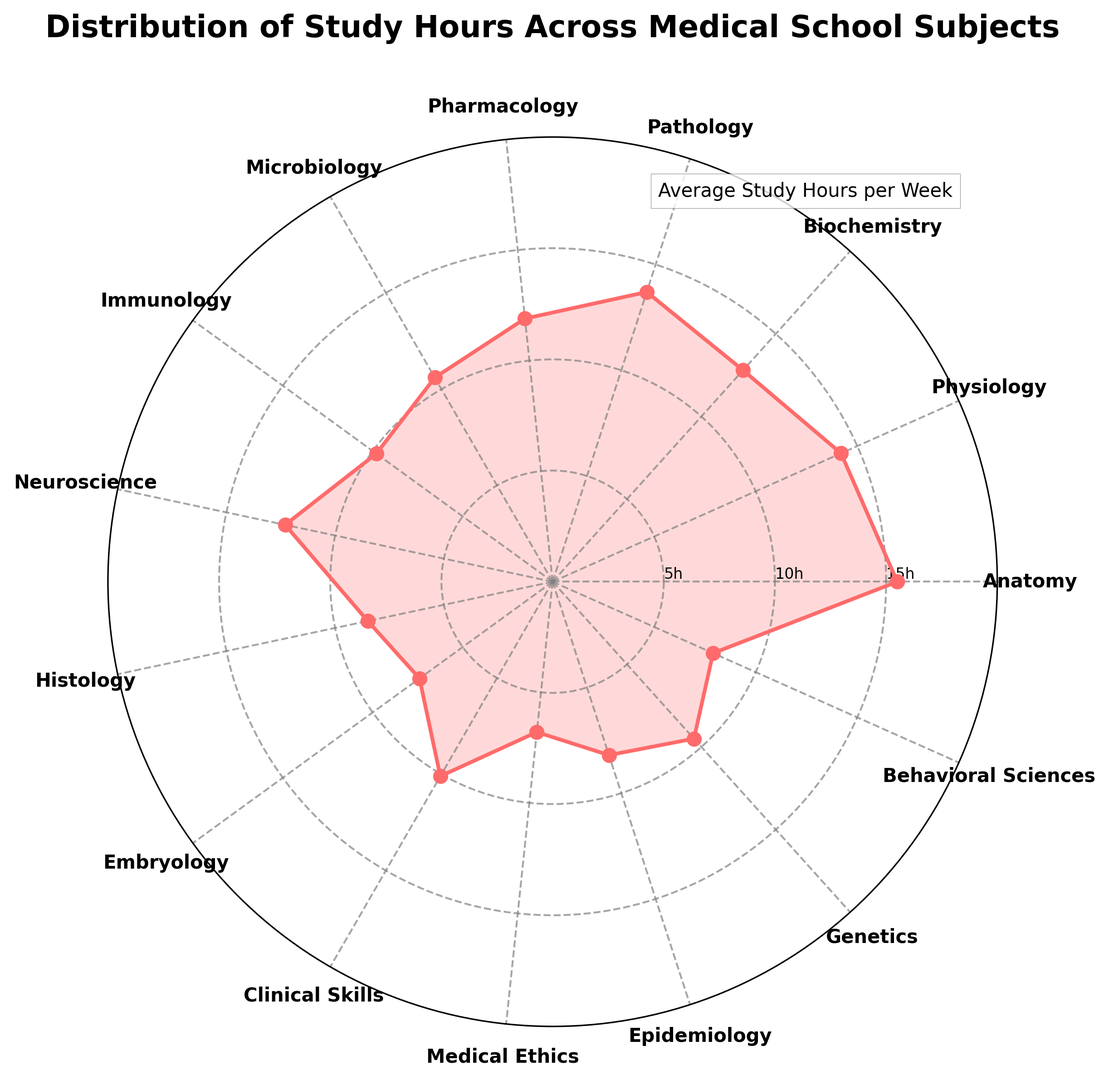Which subject requires the most study hours per week? By looking at the figure, we can see that the point corresponding to Anatomy is furthest from the center. This indicates that Anatomy has the highest average study hours per week compared to other subjects.
Answer: Anatomy Which subject requires the least study hours per week? The subject with the point closest to the center of the radar chart is Medical Ethics, indicating that it has the lowest average study hours per week.
Answer: Medical Ethics How many subjects require an average of more than 10 study hours per week? We identify the subjects with points plotted beyond the 10-hour circle on the radar chart. These subjects are Anatomy, Physiology, Biochemistry, Pathology, Pharmacology, Neuroscience, and Clinical Skills. Counting these, there are 7 subjects.
Answer: 7 What is the combined average study hours per week for Biochemistry and Pathology? From the plot, we looked at the study hours for Biochemistry (12.8 hours) and Pathology (13.7 hours). Adding these together results in 26.5 hours.
Answer: 26.5 hours Is the average study time for Neuroscience greater than for Pharmacology? Comparing the positions of Neuroscience and Pharmacology on the radar chart, we see that the point for Neuroscience is further from the center than that of Pharmacology. This indicates Neuroscience has higher average study hours per week.
Answer: Yes What's the average study time across subjects requiring less than 10 hours per week? Subjects requiring less than 10 hours per week are Histology (8.5), Embryology (7.4), Medical Ethics (6.8), Epidemiology (8.2), Genetics (9.5), and Behavioral Sciences (7.9). Summing these gives 48.3 hours, and there are 6 subjects. The average is 48.3/6 = 8.05 hours.
Answer: 8.05 hours Which subject has the closest average study hours per week to Neuroscience? Neuroscience has average study hours of 12.3. The closest subject value-wise is Biochemistry with 12.8 hours per week.
Answer: Biochemistry Are there more subjects that require less study hours than Neuroscience or more? Counting the subjects needing less than 12.3 hours (1 hour each for Microbiology, Immunology, Histology, Embryology, Clinical Skills, Medical Ethics, Epidemiology, Genetics, Behavioral Sciences - total 9), and subjects needing more or equal (Anatomy, Physiology, Biochemistry, Pathology, Pharmacology - total 5), we see that fewer subjects require more study hours than Neuroscience.
Answer: More How much more average study time does Anatomy require than Medical Ethics? Anatomy’s average study hours are 15.5, and Medical Ethics’ are 6.8. The difference is 15.5 - 6.8 = 8.7 hours per week.
Answer: 8.7 hours Among the top three subjects with the highest average study hours, what is the average study time? The top three subjects with the highest average study hours are Anatomy (15.5), Physiology (14.2), and Biochemistry (12.8). The average of these is (15.5 + 14.2 + 12.8)/3 = 14.17 hours per week.
Answer: 14.17 hours per week 